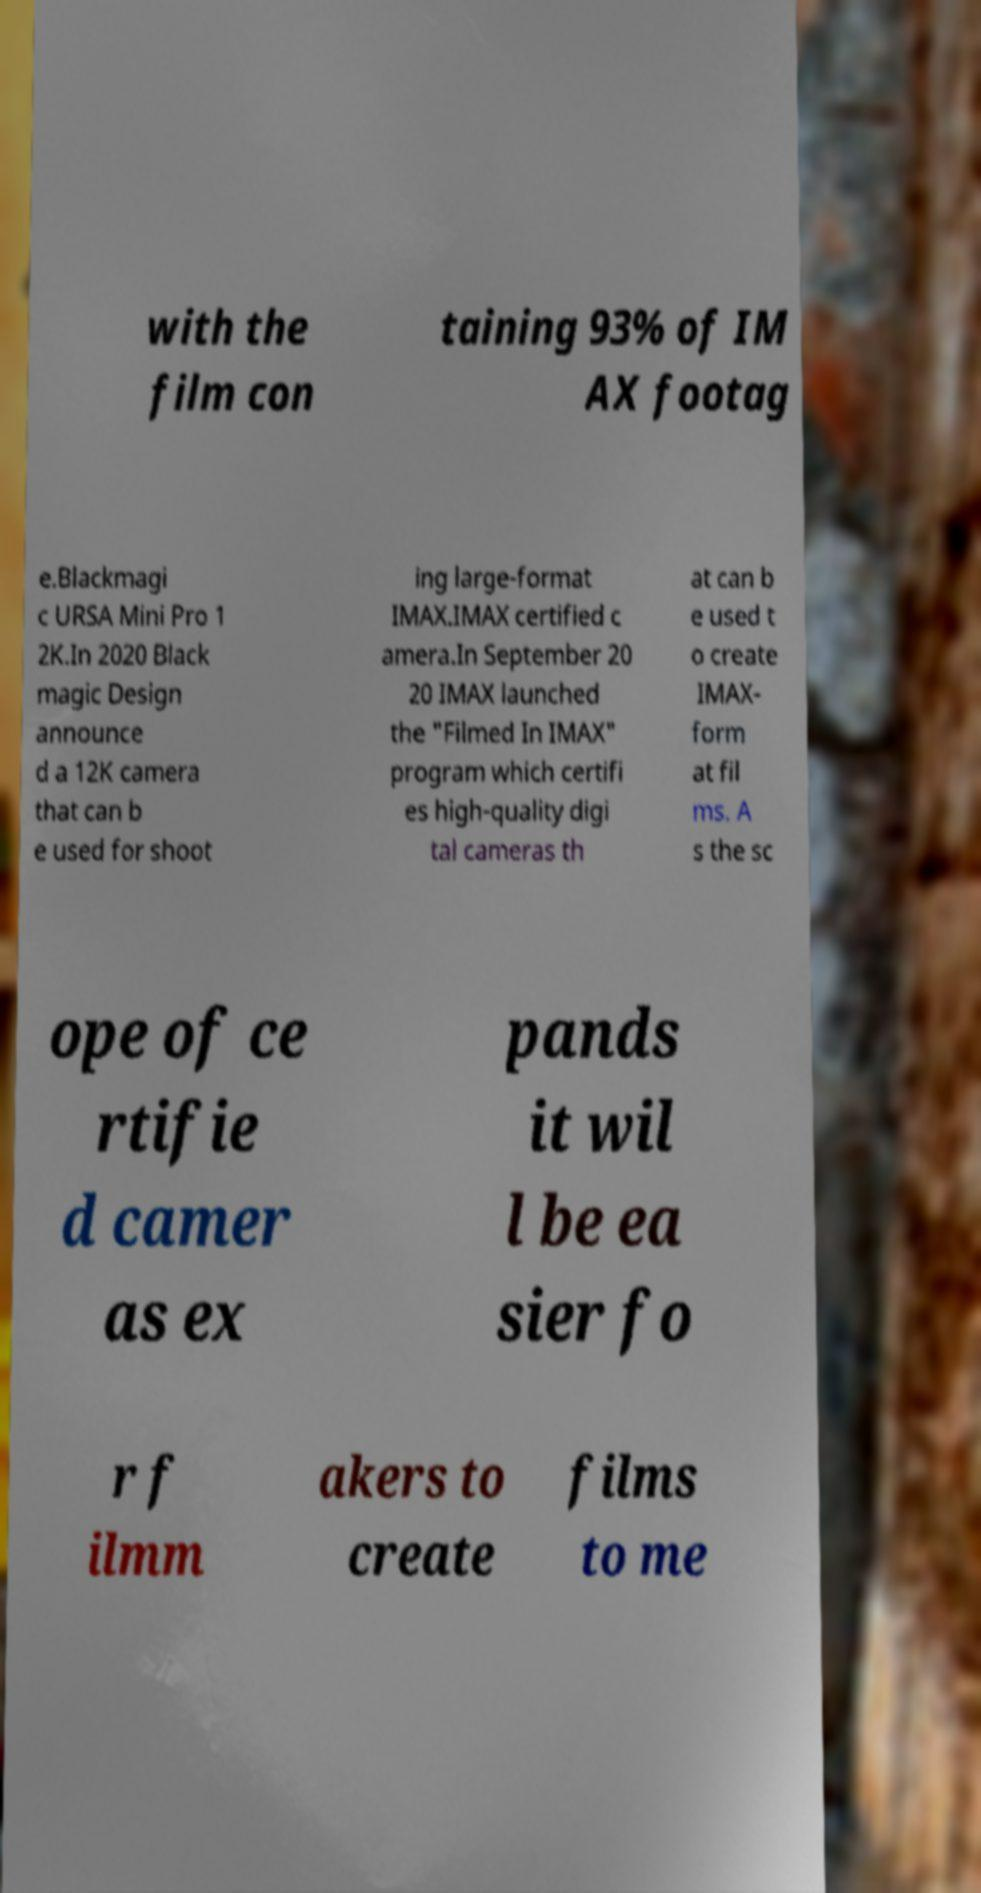For documentation purposes, I need the text within this image transcribed. Could you provide that? with the film con taining 93% of IM AX footag e.Blackmagi c URSA Mini Pro 1 2K.In 2020 Black magic Design announce d a 12K camera that can b e used for shoot ing large-format IMAX.IMAX certified c amera.In September 20 20 IMAX launched the "Filmed In IMAX" program which certifi es high-quality digi tal cameras th at can b e used t o create IMAX- form at fil ms. A s the sc ope of ce rtifie d camer as ex pands it wil l be ea sier fo r f ilmm akers to create films to me 